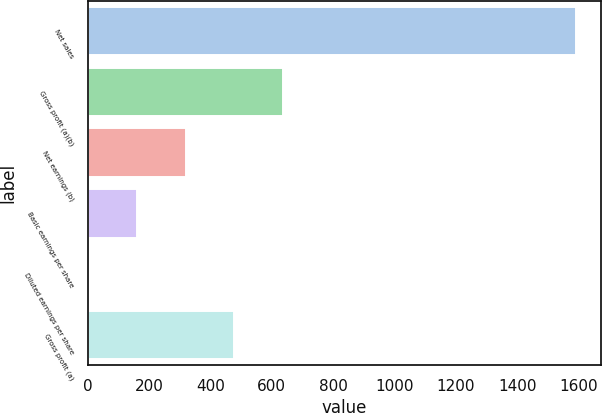<chart> <loc_0><loc_0><loc_500><loc_500><bar_chart><fcel>Net sales<fcel>Gross profit (a)(b)<fcel>Net earnings (b)<fcel>Basic earnings per share<fcel>Diluted earnings per share<fcel>Gross profit (a)<nl><fcel>1591.8<fcel>636.98<fcel>318.72<fcel>159.59<fcel>0.46<fcel>477.85<nl></chart> 